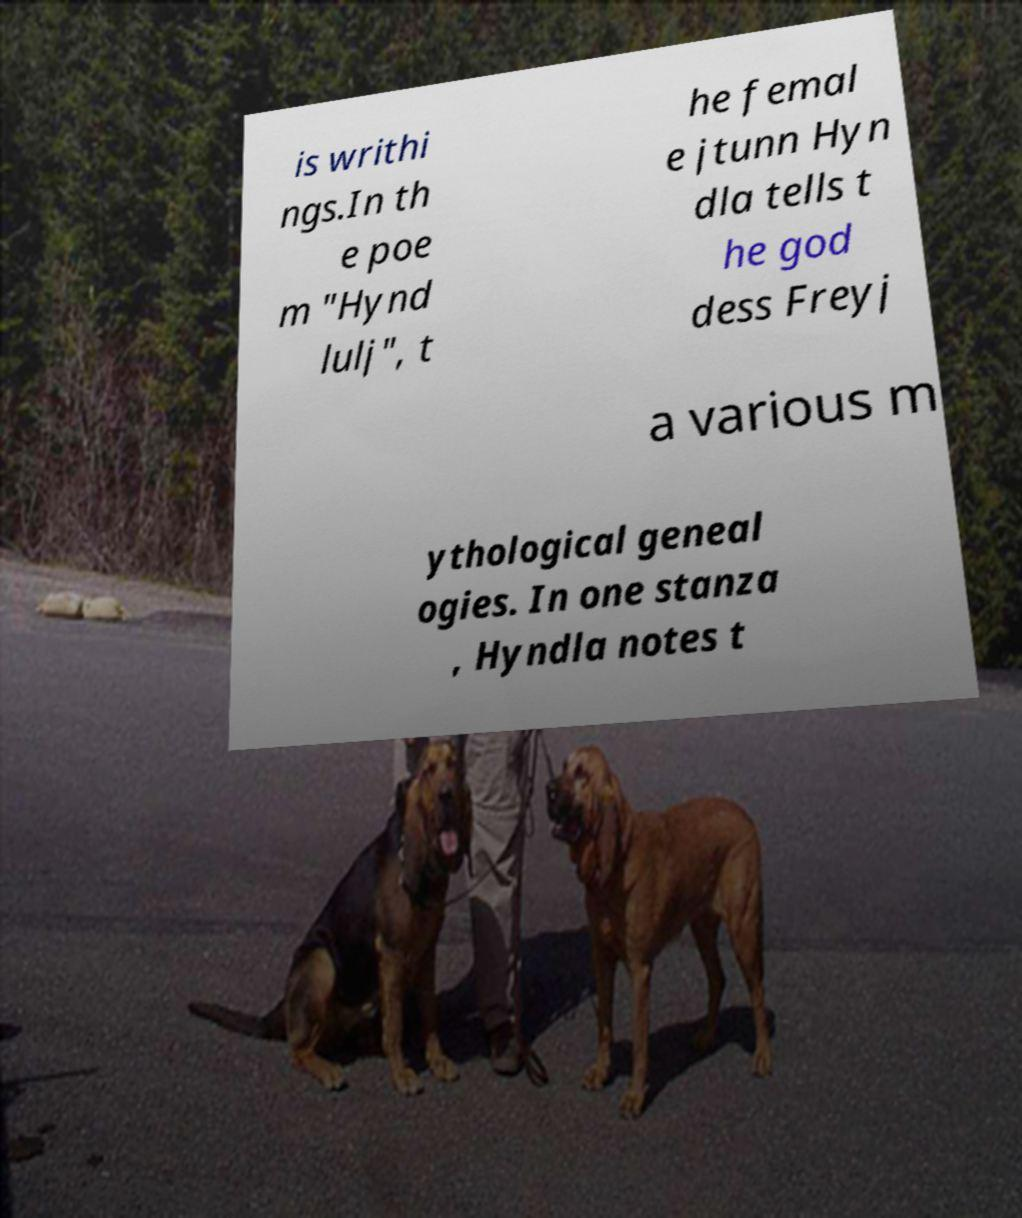For documentation purposes, I need the text within this image transcribed. Could you provide that? is writhi ngs.In th e poe m "Hynd lulj", t he femal e jtunn Hyn dla tells t he god dess Freyj a various m ythological geneal ogies. In one stanza , Hyndla notes t 